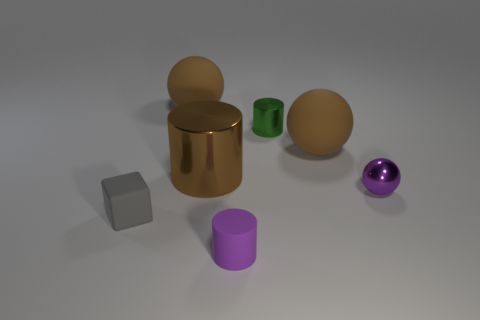There is a big metal thing; does it have the same color as the small thing behind the small metallic ball?
Give a very brief answer. No. How many blocks are tiny objects or small green shiny objects?
Offer a terse response. 1. Are there any other things of the same color as the big metallic thing?
Give a very brief answer. Yes. There is a ball left of the big rubber object to the right of the green metal cylinder; what is its material?
Provide a short and direct response. Rubber. Does the small purple cylinder have the same material as the small gray thing that is in front of the purple metallic thing?
Provide a succinct answer. Yes. How many things are tiny rubber things that are in front of the gray cube or small metallic balls?
Keep it short and to the point. 2. Are there any large cylinders of the same color as the small metallic cylinder?
Offer a terse response. No. Does the green metal object have the same shape as the brown metal thing that is on the left side of the tiny purple rubber cylinder?
Ensure brevity in your answer.  Yes. How many things are both in front of the large brown metallic cylinder and to the left of the green cylinder?
Keep it short and to the point. 2. There is a tiny green thing that is the same shape as the brown metal thing; what is its material?
Make the answer very short. Metal. 